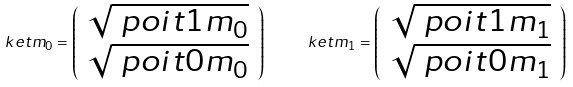<formula> <loc_0><loc_0><loc_500><loc_500>\ k e t { m _ { 0 } } = \left ( \begin{array} { c } \sqrt { \ p o i t { 1 } { m _ { 0 } } } \\ \sqrt { \ p o i t { 0 } { m _ { 0 } } } \end{array} \right ) \quad \ k e t { m _ { 1 } } = \left ( \begin{array} { c } \sqrt { \ p o i t { 1 } { m _ { 1 } } } \\ \sqrt { \ p o i t { 0 } { m _ { 1 } } } \end{array} \right )</formula> 